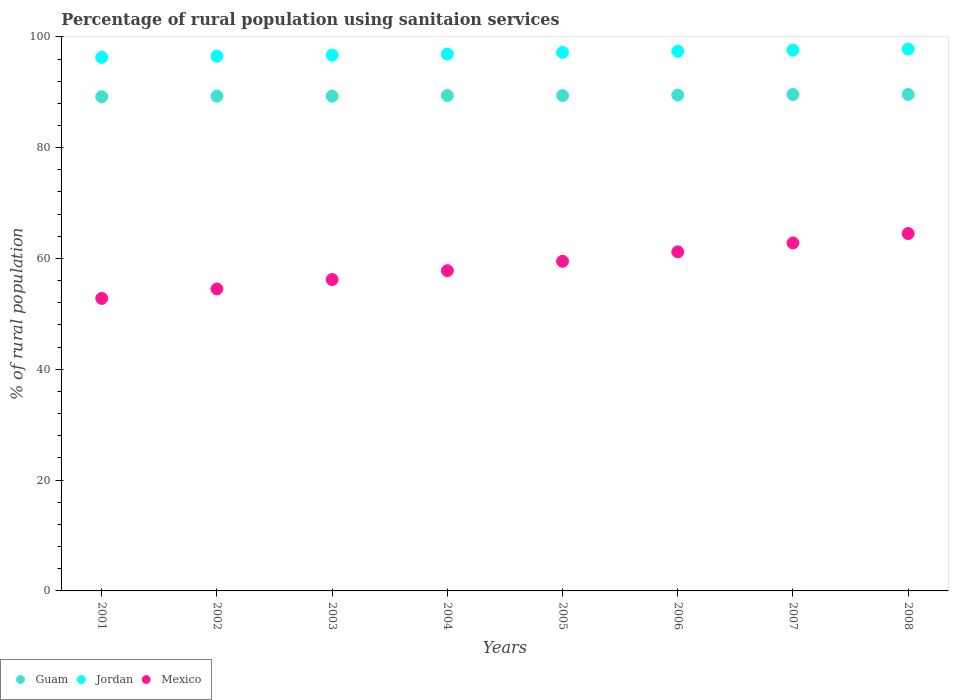Is the number of dotlines equal to the number of legend labels?
Give a very brief answer. Yes. What is the percentage of rural population using sanitaion services in Mexico in 2001?
Keep it short and to the point. 52.8. Across all years, what is the maximum percentage of rural population using sanitaion services in Mexico?
Your response must be concise. 64.5. Across all years, what is the minimum percentage of rural population using sanitaion services in Mexico?
Your answer should be compact. 52.8. In which year was the percentage of rural population using sanitaion services in Guam minimum?
Your answer should be compact. 2001. What is the total percentage of rural population using sanitaion services in Guam in the graph?
Your answer should be very brief. 715.3. What is the difference between the percentage of rural population using sanitaion services in Jordan in 2003 and that in 2006?
Your answer should be compact. -0.7. What is the difference between the percentage of rural population using sanitaion services in Mexico in 2002 and the percentage of rural population using sanitaion services in Guam in 2005?
Make the answer very short. -34.9. What is the average percentage of rural population using sanitaion services in Jordan per year?
Offer a very short reply. 97.05. In the year 2008, what is the difference between the percentage of rural population using sanitaion services in Mexico and percentage of rural population using sanitaion services in Jordan?
Keep it short and to the point. -33.3. In how many years, is the percentage of rural population using sanitaion services in Mexico greater than 60 %?
Make the answer very short. 3. What is the ratio of the percentage of rural population using sanitaion services in Mexico in 2005 to that in 2006?
Your answer should be very brief. 0.97. Is the difference between the percentage of rural population using sanitaion services in Mexico in 2004 and 2005 greater than the difference between the percentage of rural population using sanitaion services in Jordan in 2004 and 2005?
Offer a terse response. No. What is the difference between the highest and the second highest percentage of rural population using sanitaion services in Jordan?
Ensure brevity in your answer.  0.2. What is the difference between the highest and the lowest percentage of rural population using sanitaion services in Guam?
Offer a terse response. 0.4. In how many years, is the percentage of rural population using sanitaion services in Jordan greater than the average percentage of rural population using sanitaion services in Jordan taken over all years?
Offer a very short reply. 4. Is it the case that in every year, the sum of the percentage of rural population using sanitaion services in Jordan and percentage of rural population using sanitaion services in Mexico  is greater than the percentage of rural population using sanitaion services in Guam?
Give a very brief answer. Yes. What is the difference between two consecutive major ticks on the Y-axis?
Offer a terse response. 20. Does the graph contain any zero values?
Offer a terse response. No. Does the graph contain grids?
Ensure brevity in your answer.  No. Where does the legend appear in the graph?
Ensure brevity in your answer.  Bottom left. How are the legend labels stacked?
Ensure brevity in your answer.  Horizontal. What is the title of the graph?
Provide a succinct answer. Percentage of rural population using sanitaion services. What is the label or title of the X-axis?
Keep it short and to the point. Years. What is the label or title of the Y-axis?
Provide a succinct answer. % of rural population. What is the % of rural population of Guam in 2001?
Offer a very short reply. 89.2. What is the % of rural population in Jordan in 2001?
Provide a succinct answer. 96.3. What is the % of rural population in Mexico in 2001?
Make the answer very short. 52.8. What is the % of rural population in Guam in 2002?
Your answer should be compact. 89.3. What is the % of rural population of Jordan in 2002?
Your answer should be very brief. 96.5. What is the % of rural population in Mexico in 2002?
Provide a succinct answer. 54.5. What is the % of rural population of Guam in 2003?
Make the answer very short. 89.3. What is the % of rural population of Jordan in 2003?
Make the answer very short. 96.7. What is the % of rural population of Mexico in 2003?
Provide a succinct answer. 56.2. What is the % of rural population of Guam in 2004?
Your answer should be very brief. 89.4. What is the % of rural population in Jordan in 2004?
Give a very brief answer. 96.9. What is the % of rural population of Mexico in 2004?
Give a very brief answer. 57.8. What is the % of rural population in Guam in 2005?
Your answer should be compact. 89.4. What is the % of rural population in Jordan in 2005?
Give a very brief answer. 97.2. What is the % of rural population of Mexico in 2005?
Keep it short and to the point. 59.5. What is the % of rural population of Guam in 2006?
Provide a succinct answer. 89.5. What is the % of rural population of Jordan in 2006?
Ensure brevity in your answer.  97.4. What is the % of rural population of Mexico in 2006?
Keep it short and to the point. 61.2. What is the % of rural population in Guam in 2007?
Provide a short and direct response. 89.6. What is the % of rural population of Jordan in 2007?
Your answer should be compact. 97.6. What is the % of rural population of Mexico in 2007?
Give a very brief answer. 62.8. What is the % of rural population of Guam in 2008?
Offer a terse response. 89.6. What is the % of rural population in Jordan in 2008?
Offer a very short reply. 97.8. What is the % of rural population of Mexico in 2008?
Your response must be concise. 64.5. Across all years, what is the maximum % of rural population in Guam?
Keep it short and to the point. 89.6. Across all years, what is the maximum % of rural population of Jordan?
Give a very brief answer. 97.8. Across all years, what is the maximum % of rural population of Mexico?
Offer a very short reply. 64.5. Across all years, what is the minimum % of rural population in Guam?
Your answer should be compact. 89.2. Across all years, what is the minimum % of rural population in Jordan?
Your answer should be compact. 96.3. Across all years, what is the minimum % of rural population in Mexico?
Keep it short and to the point. 52.8. What is the total % of rural population of Guam in the graph?
Ensure brevity in your answer.  715.3. What is the total % of rural population in Jordan in the graph?
Offer a very short reply. 776.4. What is the total % of rural population in Mexico in the graph?
Keep it short and to the point. 469.3. What is the difference between the % of rural population in Guam in 2001 and that in 2002?
Keep it short and to the point. -0.1. What is the difference between the % of rural population in Jordan in 2001 and that in 2002?
Make the answer very short. -0.2. What is the difference between the % of rural population in Mexico in 2001 and that in 2002?
Offer a very short reply. -1.7. What is the difference between the % of rural population of Mexico in 2001 and that in 2003?
Your answer should be compact. -3.4. What is the difference between the % of rural population of Guam in 2001 and that in 2004?
Ensure brevity in your answer.  -0.2. What is the difference between the % of rural population in Mexico in 2001 and that in 2004?
Your response must be concise. -5. What is the difference between the % of rural population of Guam in 2001 and that in 2005?
Give a very brief answer. -0.2. What is the difference between the % of rural population in Guam in 2001 and that in 2006?
Give a very brief answer. -0.3. What is the difference between the % of rural population in Guam in 2001 and that in 2007?
Provide a succinct answer. -0.4. What is the difference between the % of rural population in Mexico in 2001 and that in 2007?
Offer a terse response. -10. What is the difference between the % of rural population of Guam in 2001 and that in 2008?
Give a very brief answer. -0.4. What is the difference between the % of rural population of Jordan in 2001 and that in 2008?
Offer a very short reply. -1.5. What is the difference between the % of rural population in Mexico in 2001 and that in 2008?
Provide a succinct answer. -11.7. What is the difference between the % of rural population of Mexico in 2002 and that in 2003?
Your answer should be very brief. -1.7. What is the difference between the % of rural population in Guam in 2002 and that in 2004?
Your answer should be very brief. -0.1. What is the difference between the % of rural population in Jordan in 2002 and that in 2004?
Ensure brevity in your answer.  -0.4. What is the difference between the % of rural population of Mexico in 2002 and that in 2004?
Offer a terse response. -3.3. What is the difference between the % of rural population of Guam in 2002 and that in 2005?
Make the answer very short. -0.1. What is the difference between the % of rural population of Guam in 2002 and that in 2006?
Your answer should be compact. -0.2. What is the difference between the % of rural population in Guam in 2002 and that in 2007?
Offer a very short reply. -0.3. What is the difference between the % of rural population in Guam in 2002 and that in 2008?
Provide a short and direct response. -0.3. What is the difference between the % of rural population in Jordan in 2002 and that in 2008?
Your answer should be very brief. -1.3. What is the difference between the % of rural population of Jordan in 2003 and that in 2005?
Your answer should be very brief. -0.5. What is the difference between the % of rural population of Guam in 2003 and that in 2006?
Give a very brief answer. -0.2. What is the difference between the % of rural population of Mexico in 2003 and that in 2006?
Make the answer very short. -5. What is the difference between the % of rural population in Jordan in 2003 and that in 2007?
Keep it short and to the point. -0.9. What is the difference between the % of rural population in Mexico in 2003 and that in 2007?
Ensure brevity in your answer.  -6.6. What is the difference between the % of rural population of Guam in 2003 and that in 2008?
Ensure brevity in your answer.  -0.3. What is the difference between the % of rural population of Mexico in 2003 and that in 2008?
Offer a very short reply. -8.3. What is the difference between the % of rural population of Guam in 2004 and that in 2006?
Provide a short and direct response. -0.1. What is the difference between the % of rural population in Mexico in 2004 and that in 2006?
Your response must be concise. -3.4. What is the difference between the % of rural population of Guam in 2004 and that in 2007?
Your answer should be very brief. -0.2. What is the difference between the % of rural population in Jordan in 2004 and that in 2007?
Provide a succinct answer. -0.7. What is the difference between the % of rural population in Guam in 2004 and that in 2008?
Provide a short and direct response. -0.2. What is the difference between the % of rural population of Jordan in 2004 and that in 2008?
Your answer should be very brief. -0.9. What is the difference between the % of rural population in Mexico in 2004 and that in 2008?
Your response must be concise. -6.7. What is the difference between the % of rural population of Guam in 2005 and that in 2007?
Your response must be concise. -0.2. What is the difference between the % of rural population in Jordan in 2005 and that in 2007?
Offer a terse response. -0.4. What is the difference between the % of rural population of Guam in 2005 and that in 2008?
Offer a terse response. -0.2. What is the difference between the % of rural population of Mexico in 2005 and that in 2008?
Provide a succinct answer. -5. What is the difference between the % of rural population of Guam in 2006 and that in 2008?
Your answer should be very brief. -0.1. What is the difference between the % of rural population of Guam in 2001 and the % of rural population of Mexico in 2002?
Make the answer very short. 34.7. What is the difference between the % of rural population in Jordan in 2001 and the % of rural population in Mexico in 2002?
Offer a very short reply. 41.8. What is the difference between the % of rural population of Guam in 2001 and the % of rural population of Jordan in 2003?
Your response must be concise. -7.5. What is the difference between the % of rural population of Jordan in 2001 and the % of rural population of Mexico in 2003?
Offer a very short reply. 40.1. What is the difference between the % of rural population of Guam in 2001 and the % of rural population of Mexico in 2004?
Make the answer very short. 31.4. What is the difference between the % of rural population in Jordan in 2001 and the % of rural population in Mexico in 2004?
Your response must be concise. 38.5. What is the difference between the % of rural population in Guam in 2001 and the % of rural population in Mexico in 2005?
Your answer should be very brief. 29.7. What is the difference between the % of rural population in Jordan in 2001 and the % of rural population in Mexico in 2005?
Your response must be concise. 36.8. What is the difference between the % of rural population of Guam in 2001 and the % of rural population of Jordan in 2006?
Offer a terse response. -8.2. What is the difference between the % of rural population in Jordan in 2001 and the % of rural population in Mexico in 2006?
Your answer should be compact. 35.1. What is the difference between the % of rural population of Guam in 2001 and the % of rural population of Mexico in 2007?
Your answer should be compact. 26.4. What is the difference between the % of rural population of Jordan in 2001 and the % of rural population of Mexico in 2007?
Provide a short and direct response. 33.5. What is the difference between the % of rural population of Guam in 2001 and the % of rural population of Mexico in 2008?
Offer a very short reply. 24.7. What is the difference between the % of rural population of Jordan in 2001 and the % of rural population of Mexico in 2008?
Keep it short and to the point. 31.8. What is the difference between the % of rural population of Guam in 2002 and the % of rural population of Mexico in 2003?
Provide a succinct answer. 33.1. What is the difference between the % of rural population in Jordan in 2002 and the % of rural population in Mexico in 2003?
Offer a terse response. 40.3. What is the difference between the % of rural population in Guam in 2002 and the % of rural population in Jordan in 2004?
Offer a very short reply. -7.6. What is the difference between the % of rural population in Guam in 2002 and the % of rural population in Mexico in 2004?
Your answer should be compact. 31.5. What is the difference between the % of rural population of Jordan in 2002 and the % of rural population of Mexico in 2004?
Your answer should be very brief. 38.7. What is the difference between the % of rural population of Guam in 2002 and the % of rural population of Mexico in 2005?
Make the answer very short. 29.8. What is the difference between the % of rural population of Jordan in 2002 and the % of rural population of Mexico in 2005?
Ensure brevity in your answer.  37. What is the difference between the % of rural population in Guam in 2002 and the % of rural population in Jordan in 2006?
Offer a very short reply. -8.1. What is the difference between the % of rural population of Guam in 2002 and the % of rural population of Mexico in 2006?
Offer a terse response. 28.1. What is the difference between the % of rural population of Jordan in 2002 and the % of rural population of Mexico in 2006?
Ensure brevity in your answer.  35.3. What is the difference between the % of rural population of Jordan in 2002 and the % of rural population of Mexico in 2007?
Ensure brevity in your answer.  33.7. What is the difference between the % of rural population of Guam in 2002 and the % of rural population of Mexico in 2008?
Make the answer very short. 24.8. What is the difference between the % of rural population of Guam in 2003 and the % of rural population of Mexico in 2004?
Keep it short and to the point. 31.5. What is the difference between the % of rural population of Jordan in 2003 and the % of rural population of Mexico in 2004?
Your answer should be very brief. 38.9. What is the difference between the % of rural population in Guam in 2003 and the % of rural population in Jordan in 2005?
Provide a succinct answer. -7.9. What is the difference between the % of rural population of Guam in 2003 and the % of rural population of Mexico in 2005?
Give a very brief answer. 29.8. What is the difference between the % of rural population of Jordan in 2003 and the % of rural population of Mexico in 2005?
Give a very brief answer. 37.2. What is the difference between the % of rural population in Guam in 2003 and the % of rural population in Jordan in 2006?
Provide a short and direct response. -8.1. What is the difference between the % of rural population of Guam in 2003 and the % of rural population of Mexico in 2006?
Your answer should be compact. 28.1. What is the difference between the % of rural population in Jordan in 2003 and the % of rural population in Mexico in 2006?
Provide a succinct answer. 35.5. What is the difference between the % of rural population in Guam in 2003 and the % of rural population in Jordan in 2007?
Keep it short and to the point. -8.3. What is the difference between the % of rural population of Jordan in 2003 and the % of rural population of Mexico in 2007?
Your answer should be compact. 33.9. What is the difference between the % of rural population of Guam in 2003 and the % of rural population of Jordan in 2008?
Provide a succinct answer. -8.5. What is the difference between the % of rural population in Guam in 2003 and the % of rural population in Mexico in 2008?
Provide a succinct answer. 24.8. What is the difference between the % of rural population of Jordan in 2003 and the % of rural population of Mexico in 2008?
Your answer should be very brief. 32.2. What is the difference between the % of rural population in Guam in 2004 and the % of rural population in Mexico in 2005?
Provide a short and direct response. 29.9. What is the difference between the % of rural population of Jordan in 2004 and the % of rural population of Mexico in 2005?
Ensure brevity in your answer.  37.4. What is the difference between the % of rural population of Guam in 2004 and the % of rural population of Jordan in 2006?
Your answer should be very brief. -8. What is the difference between the % of rural population in Guam in 2004 and the % of rural population in Mexico in 2006?
Make the answer very short. 28.2. What is the difference between the % of rural population of Jordan in 2004 and the % of rural population of Mexico in 2006?
Keep it short and to the point. 35.7. What is the difference between the % of rural population of Guam in 2004 and the % of rural population of Jordan in 2007?
Provide a succinct answer. -8.2. What is the difference between the % of rural population in Guam in 2004 and the % of rural population in Mexico in 2007?
Make the answer very short. 26.6. What is the difference between the % of rural population of Jordan in 2004 and the % of rural population of Mexico in 2007?
Keep it short and to the point. 34.1. What is the difference between the % of rural population of Guam in 2004 and the % of rural population of Jordan in 2008?
Give a very brief answer. -8.4. What is the difference between the % of rural population of Guam in 2004 and the % of rural population of Mexico in 2008?
Provide a short and direct response. 24.9. What is the difference between the % of rural population in Jordan in 2004 and the % of rural population in Mexico in 2008?
Keep it short and to the point. 32.4. What is the difference between the % of rural population of Guam in 2005 and the % of rural population of Jordan in 2006?
Provide a succinct answer. -8. What is the difference between the % of rural population in Guam in 2005 and the % of rural population in Mexico in 2006?
Offer a very short reply. 28.2. What is the difference between the % of rural population in Jordan in 2005 and the % of rural population in Mexico in 2006?
Make the answer very short. 36. What is the difference between the % of rural population in Guam in 2005 and the % of rural population in Mexico in 2007?
Your answer should be compact. 26.6. What is the difference between the % of rural population of Jordan in 2005 and the % of rural population of Mexico in 2007?
Make the answer very short. 34.4. What is the difference between the % of rural population in Guam in 2005 and the % of rural population in Jordan in 2008?
Offer a very short reply. -8.4. What is the difference between the % of rural population in Guam in 2005 and the % of rural population in Mexico in 2008?
Ensure brevity in your answer.  24.9. What is the difference between the % of rural population in Jordan in 2005 and the % of rural population in Mexico in 2008?
Give a very brief answer. 32.7. What is the difference between the % of rural population in Guam in 2006 and the % of rural population in Jordan in 2007?
Keep it short and to the point. -8.1. What is the difference between the % of rural population of Guam in 2006 and the % of rural population of Mexico in 2007?
Provide a short and direct response. 26.7. What is the difference between the % of rural population of Jordan in 2006 and the % of rural population of Mexico in 2007?
Make the answer very short. 34.6. What is the difference between the % of rural population of Guam in 2006 and the % of rural population of Mexico in 2008?
Offer a very short reply. 25. What is the difference between the % of rural population in Jordan in 2006 and the % of rural population in Mexico in 2008?
Your answer should be very brief. 32.9. What is the difference between the % of rural population of Guam in 2007 and the % of rural population of Mexico in 2008?
Your response must be concise. 25.1. What is the difference between the % of rural population of Jordan in 2007 and the % of rural population of Mexico in 2008?
Provide a short and direct response. 33.1. What is the average % of rural population in Guam per year?
Offer a terse response. 89.41. What is the average % of rural population in Jordan per year?
Keep it short and to the point. 97.05. What is the average % of rural population in Mexico per year?
Make the answer very short. 58.66. In the year 2001, what is the difference between the % of rural population in Guam and % of rural population in Jordan?
Your answer should be compact. -7.1. In the year 2001, what is the difference between the % of rural population in Guam and % of rural population in Mexico?
Your response must be concise. 36.4. In the year 2001, what is the difference between the % of rural population of Jordan and % of rural population of Mexico?
Keep it short and to the point. 43.5. In the year 2002, what is the difference between the % of rural population of Guam and % of rural population of Jordan?
Your response must be concise. -7.2. In the year 2002, what is the difference between the % of rural population of Guam and % of rural population of Mexico?
Offer a terse response. 34.8. In the year 2003, what is the difference between the % of rural population of Guam and % of rural population of Mexico?
Offer a very short reply. 33.1. In the year 2003, what is the difference between the % of rural population in Jordan and % of rural population in Mexico?
Make the answer very short. 40.5. In the year 2004, what is the difference between the % of rural population in Guam and % of rural population in Mexico?
Your answer should be compact. 31.6. In the year 2004, what is the difference between the % of rural population of Jordan and % of rural population of Mexico?
Offer a terse response. 39.1. In the year 2005, what is the difference between the % of rural population of Guam and % of rural population of Jordan?
Keep it short and to the point. -7.8. In the year 2005, what is the difference between the % of rural population of Guam and % of rural population of Mexico?
Provide a succinct answer. 29.9. In the year 2005, what is the difference between the % of rural population in Jordan and % of rural population in Mexico?
Give a very brief answer. 37.7. In the year 2006, what is the difference between the % of rural population in Guam and % of rural population in Mexico?
Your response must be concise. 28.3. In the year 2006, what is the difference between the % of rural population in Jordan and % of rural population in Mexico?
Your answer should be very brief. 36.2. In the year 2007, what is the difference between the % of rural population in Guam and % of rural population in Mexico?
Your answer should be very brief. 26.8. In the year 2007, what is the difference between the % of rural population in Jordan and % of rural population in Mexico?
Provide a succinct answer. 34.8. In the year 2008, what is the difference between the % of rural population of Guam and % of rural population of Mexico?
Offer a terse response. 25.1. In the year 2008, what is the difference between the % of rural population in Jordan and % of rural population in Mexico?
Provide a short and direct response. 33.3. What is the ratio of the % of rural population of Guam in 2001 to that in 2002?
Keep it short and to the point. 1. What is the ratio of the % of rural population in Jordan in 2001 to that in 2002?
Ensure brevity in your answer.  1. What is the ratio of the % of rural population in Mexico in 2001 to that in 2002?
Your answer should be very brief. 0.97. What is the ratio of the % of rural population in Guam in 2001 to that in 2003?
Offer a very short reply. 1. What is the ratio of the % of rural population in Jordan in 2001 to that in 2003?
Give a very brief answer. 1. What is the ratio of the % of rural population in Mexico in 2001 to that in 2003?
Offer a very short reply. 0.94. What is the ratio of the % of rural population in Mexico in 2001 to that in 2004?
Your answer should be compact. 0.91. What is the ratio of the % of rural population in Mexico in 2001 to that in 2005?
Your answer should be compact. 0.89. What is the ratio of the % of rural population of Jordan in 2001 to that in 2006?
Give a very brief answer. 0.99. What is the ratio of the % of rural population of Mexico in 2001 to that in 2006?
Your answer should be very brief. 0.86. What is the ratio of the % of rural population of Jordan in 2001 to that in 2007?
Provide a short and direct response. 0.99. What is the ratio of the % of rural population of Mexico in 2001 to that in 2007?
Provide a short and direct response. 0.84. What is the ratio of the % of rural population of Guam in 2001 to that in 2008?
Your response must be concise. 1. What is the ratio of the % of rural population of Jordan in 2001 to that in 2008?
Offer a very short reply. 0.98. What is the ratio of the % of rural population in Mexico in 2001 to that in 2008?
Your answer should be compact. 0.82. What is the ratio of the % of rural population of Mexico in 2002 to that in 2003?
Make the answer very short. 0.97. What is the ratio of the % of rural population of Guam in 2002 to that in 2004?
Offer a very short reply. 1. What is the ratio of the % of rural population in Jordan in 2002 to that in 2004?
Offer a very short reply. 1. What is the ratio of the % of rural population in Mexico in 2002 to that in 2004?
Provide a succinct answer. 0.94. What is the ratio of the % of rural population in Mexico in 2002 to that in 2005?
Your answer should be compact. 0.92. What is the ratio of the % of rural population in Guam in 2002 to that in 2006?
Provide a short and direct response. 1. What is the ratio of the % of rural population in Jordan in 2002 to that in 2006?
Your answer should be compact. 0.99. What is the ratio of the % of rural population in Mexico in 2002 to that in 2006?
Your response must be concise. 0.89. What is the ratio of the % of rural population of Guam in 2002 to that in 2007?
Keep it short and to the point. 1. What is the ratio of the % of rural population in Jordan in 2002 to that in 2007?
Offer a terse response. 0.99. What is the ratio of the % of rural population in Mexico in 2002 to that in 2007?
Keep it short and to the point. 0.87. What is the ratio of the % of rural population in Jordan in 2002 to that in 2008?
Offer a very short reply. 0.99. What is the ratio of the % of rural population in Mexico in 2002 to that in 2008?
Provide a succinct answer. 0.84. What is the ratio of the % of rural population of Jordan in 2003 to that in 2004?
Make the answer very short. 1. What is the ratio of the % of rural population of Mexico in 2003 to that in 2004?
Your answer should be very brief. 0.97. What is the ratio of the % of rural population of Guam in 2003 to that in 2005?
Ensure brevity in your answer.  1. What is the ratio of the % of rural population in Jordan in 2003 to that in 2005?
Your answer should be very brief. 0.99. What is the ratio of the % of rural population in Mexico in 2003 to that in 2005?
Make the answer very short. 0.94. What is the ratio of the % of rural population in Guam in 2003 to that in 2006?
Provide a short and direct response. 1. What is the ratio of the % of rural population in Jordan in 2003 to that in 2006?
Provide a succinct answer. 0.99. What is the ratio of the % of rural population in Mexico in 2003 to that in 2006?
Offer a very short reply. 0.92. What is the ratio of the % of rural population in Guam in 2003 to that in 2007?
Make the answer very short. 1. What is the ratio of the % of rural population in Jordan in 2003 to that in 2007?
Make the answer very short. 0.99. What is the ratio of the % of rural population of Mexico in 2003 to that in 2007?
Keep it short and to the point. 0.89. What is the ratio of the % of rural population of Guam in 2003 to that in 2008?
Provide a succinct answer. 1. What is the ratio of the % of rural population in Jordan in 2003 to that in 2008?
Offer a very short reply. 0.99. What is the ratio of the % of rural population in Mexico in 2003 to that in 2008?
Your response must be concise. 0.87. What is the ratio of the % of rural population in Mexico in 2004 to that in 2005?
Your answer should be compact. 0.97. What is the ratio of the % of rural population in Guam in 2004 to that in 2006?
Provide a short and direct response. 1. What is the ratio of the % of rural population in Guam in 2004 to that in 2007?
Your answer should be very brief. 1. What is the ratio of the % of rural population in Mexico in 2004 to that in 2007?
Ensure brevity in your answer.  0.92. What is the ratio of the % of rural population in Guam in 2004 to that in 2008?
Your response must be concise. 1. What is the ratio of the % of rural population in Jordan in 2004 to that in 2008?
Your response must be concise. 0.99. What is the ratio of the % of rural population of Mexico in 2004 to that in 2008?
Your answer should be very brief. 0.9. What is the ratio of the % of rural population of Mexico in 2005 to that in 2006?
Your answer should be compact. 0.97. What is the ratio of the % of rural population of Mexico in 2005 to that in 2007?
Make the answer very short. 0.95. What is the ratio of the % of rural population in Guam in 2005 to that in 2008?
Give a very brief answer. 1. What is the ratio of the % of rural population of Mexico in 2005 to that in 2008?
Provide a succinct answer. 0.92. What is the ratio of the % of rural population in Guam in 2006 to that in 2007?
Keep it short and to the point. 1. What is the ratio of the % of rural population in Mexico in 2006 to that in 2007?
Make the answer very short. 0.97. What is the ratio of the % of rural population of Guam in 2006 to that in 2008?
Provide a short and direct response. 1. What is the ratio of the % of rural population of Jordan in 2006 to that in 2008?
Your answer should be very brief. 1. What is the ratio of the % of rural population of Mexico in 2006 to that in 2008?
Offer a very short reply. 0.95. What is the ratio of the % of rural population of Guam in 2007 to that in 2008?
Provide a short and direct response. 1. What is the ratio of the % of rural population in Jordan in 2007 to that in 2008?
Offer a terse response. 1. What is the ratio of the % of rural population of Mexico in 2007 to that in 2008?
Keep it short and to the point. 0.97. What is the difference between the highest and the second highest % of rural population in Guam?
Your answer should be compact. 0. What is the difference between the highest and the second highest % of rural population of Mexico?
Give a very brief answer. 1.7. What is the difference between the highest and the lowest % of rural population of Guam?
Provide a succinct answer. 0.4. What is the difference between the highest and the lowest % of rural population in Jordan?
Offer a very short reply. 1.5. 